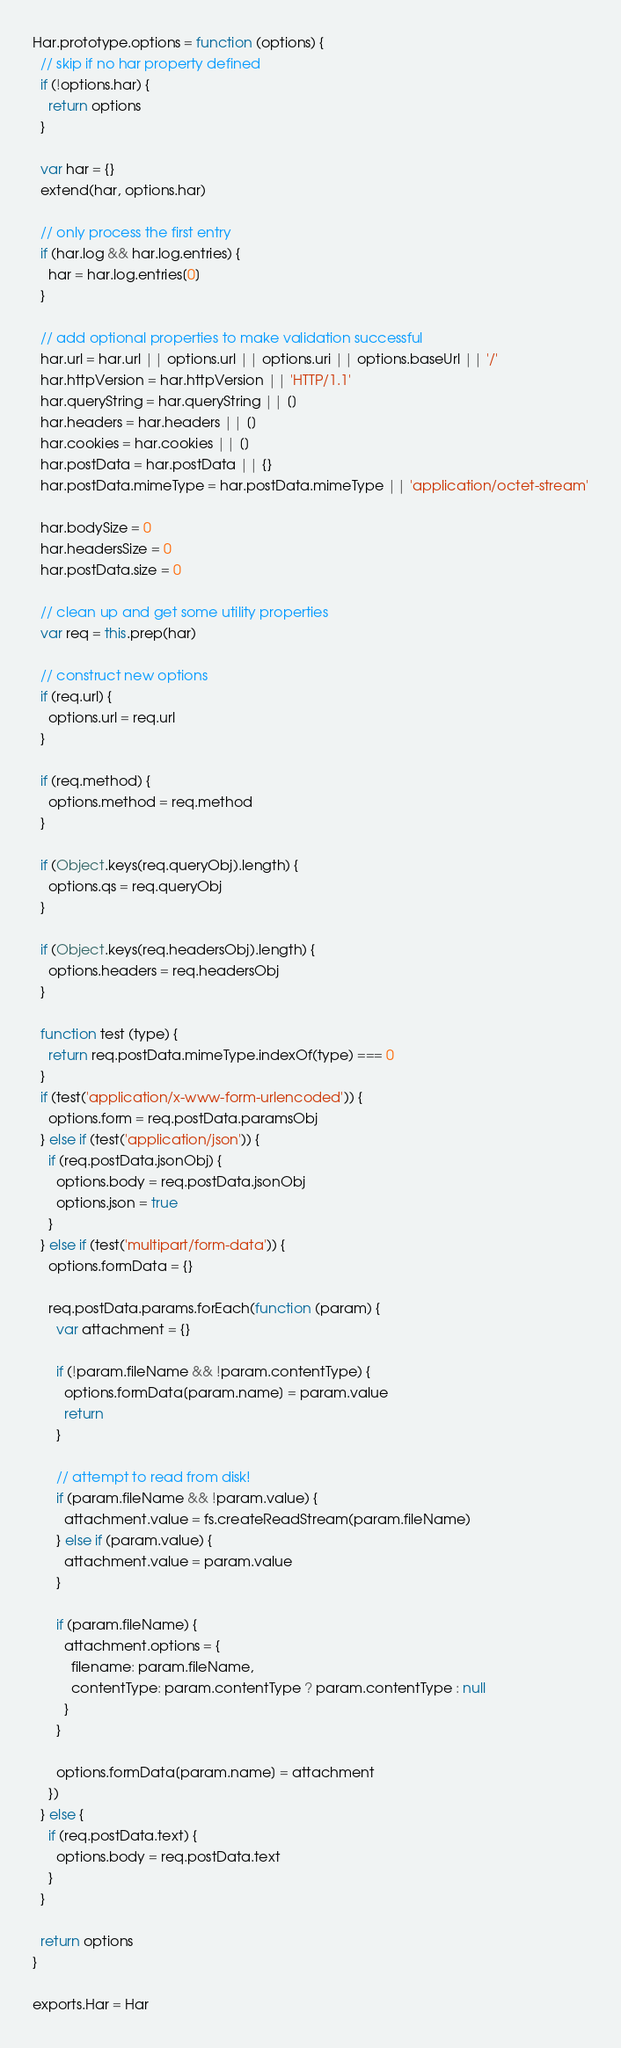<code> <loc_0><loc_0><loc_500><loc_500><_JavaScript_>Har.prototype.options = function (options) {
  // skip if no har property defined
  if (!options.har) {
    return options
  }

  var har = {}
  extend(har, options.har)

  // only process the first entry
  if (har.log && har.log.entries) {
    har = har.log.entries[0]
  }

  // add optional properties to make validation successful
  har.url = har.url || options.url || options.uri || options.baseUrl || '/'
  har.httpVersion = har.httpVersion || 'HTTP/1.1'
  har.queryString = har.queryString || []
  har.headers = har.headers || []
  har.cookies = har.cookies || []
  har.postData = har.postData || {}
  har.postData.mimeType = har.postData.mimeType || 'application/octet-stream'

  har.bodySize = 0
  har.headersSize = 0
  har.postData.size = 0

  // clean up and get some utility properties
  var req = this.prep(har)

  // construct new options
  if (req.url) {
    options.url = req.url
  }

  if (req.method) {
    options.method = req.method
  }

  if (Object.keys(req.queryObj).length) {
    options.qs = req.queryObj
  }

  if (Object.keys(req.headersObj).length) {
    options.headers = req.headersObj
  }

  function test (type) {
    return req.postData.mimeType.indexOf(type) === 0
  }
  if (test('application/x-www-form-urlencoded')) {
    options.form = req.postData.paramsObj
  } else if (test('application/json')) {
    if (req.postData.jsonObj) {
      options.body = req.postData.jsonObj
      options.json = true
    }
  } else if (test('multipart/form-data')) {
    options.formData = {}

    req.postData.params.forEach(function (param) {
      var attachment = {}

      if (!param.fileName && !param.contentType) {
        options.formData[param.name] = param.value
        return
      }

      // attempt to read from disk!
      if (param.fileName && !param.value) {
        attachment.value = fs.createReadStream(param.fileName)
      } else if (param.value) {
        attachment.value = param.value
      }

      if (param.fileName) {
        attachment.options = {
          filename: param.fileName,
          contentType: param.contentType ? param.contentType : null
        }
      }

      options.formData[param.name] = attachment
    })
  } else {
    if (req.postData.text) {
      options.body = req.postData.text
    }
  }

  return options
}

exports.Har = Har
</code> 